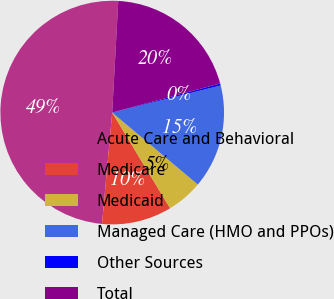<chart> <loc_0><loc_0><loc_500><loc_500><pie_chart><fcel>Acute Care and Behavioral<fcel>Medicare<fcel>Medicaid<fcel>Managed Care (HMO and PPOs)<fcel>Other Sources<fcel>Total<nl><fcel>49.41%<fcel>10.12%<fcel>5.21%<fcel>15.03%<fcel>0.29%<fcel>19.94%<nl></chart> 